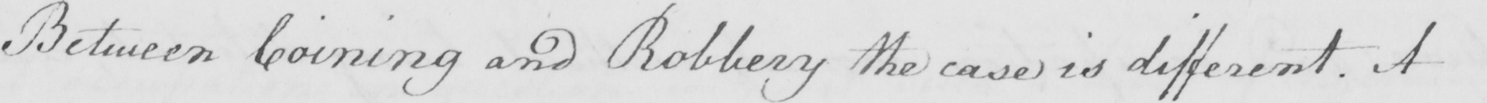Please provide the text content of this handwritten line. Between Coining and Robbery the case is different . A 